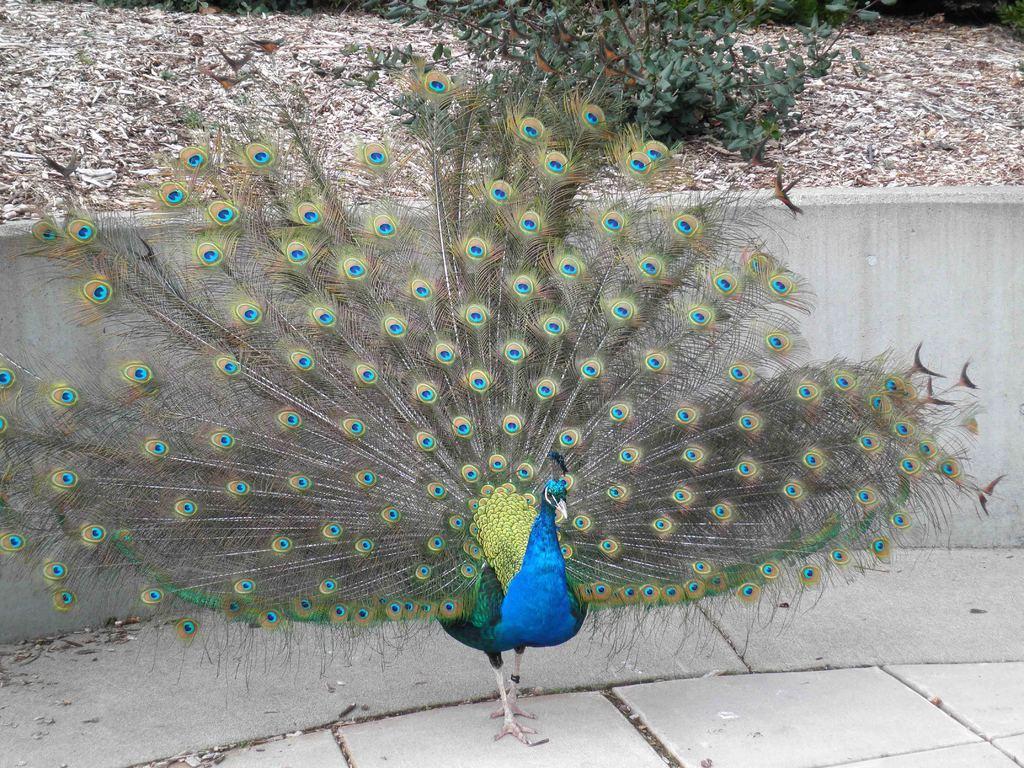Could you give a brief overview of what you see in this image? In this picture there is a peacock who is standing near to the wall. At the top I can see the plants and leaves. 